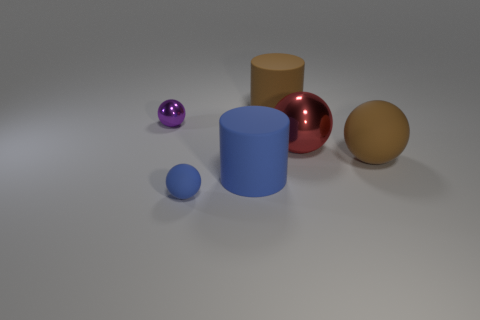Subtract all tiny purple shiny balls. How many balls are left? 3 Add 3 tiny cyan rubber cylinders. How many objects exist? 9 Subtract all blue balls. How many balls are left? 3 Subtract all purple cylinders. How many red balls are left? 1 Subtract all spheres. How many objects are left? 2 Subtract 1 cylinders. How many cylinders are left? 1 Subtract 0 gray blocks. How many objects are left? 6 Subtract all gray cylinders. Subtract all gray blocks. How many cylinders are left? 2 Subtract all yellow shiny cylinders. Subtract all large red balls. How many objects are left? 5 Add 4 small blue things. How many small blue things are left? 5 